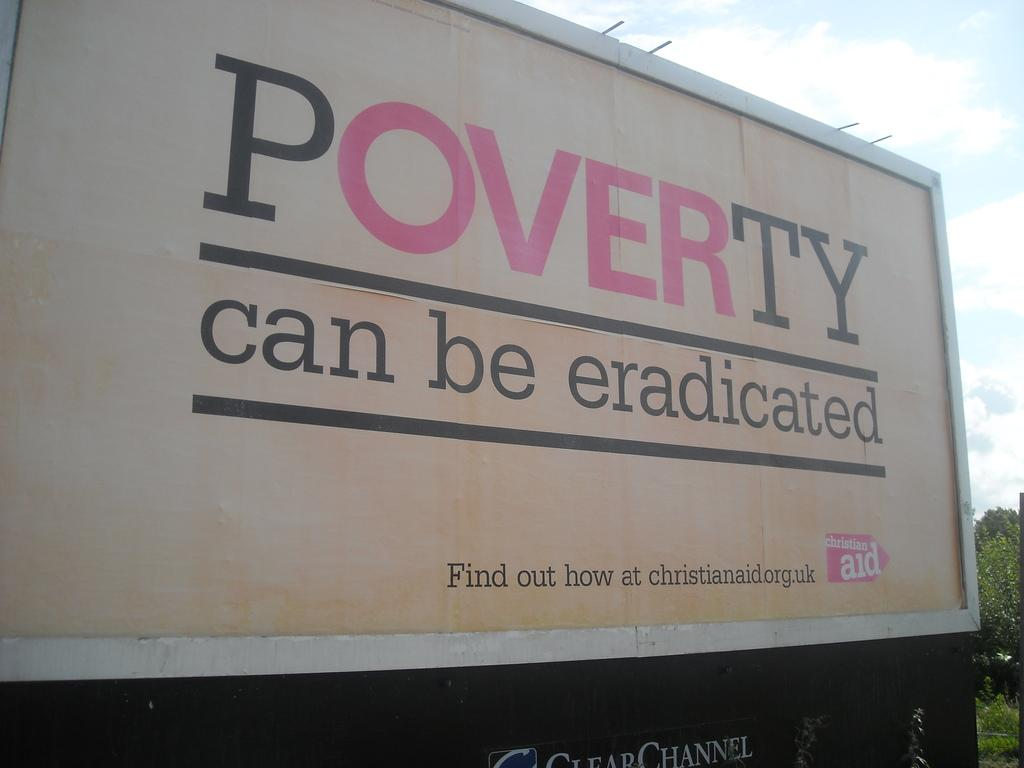<image>
Provide a brief description of the given image. a billboard that says 'poverty can be eradicated' on it 